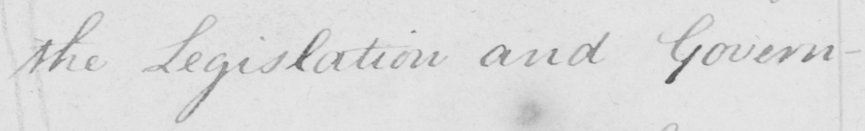Transcribe the text shown in this historical manuscript line. the Legislation and Govern- 